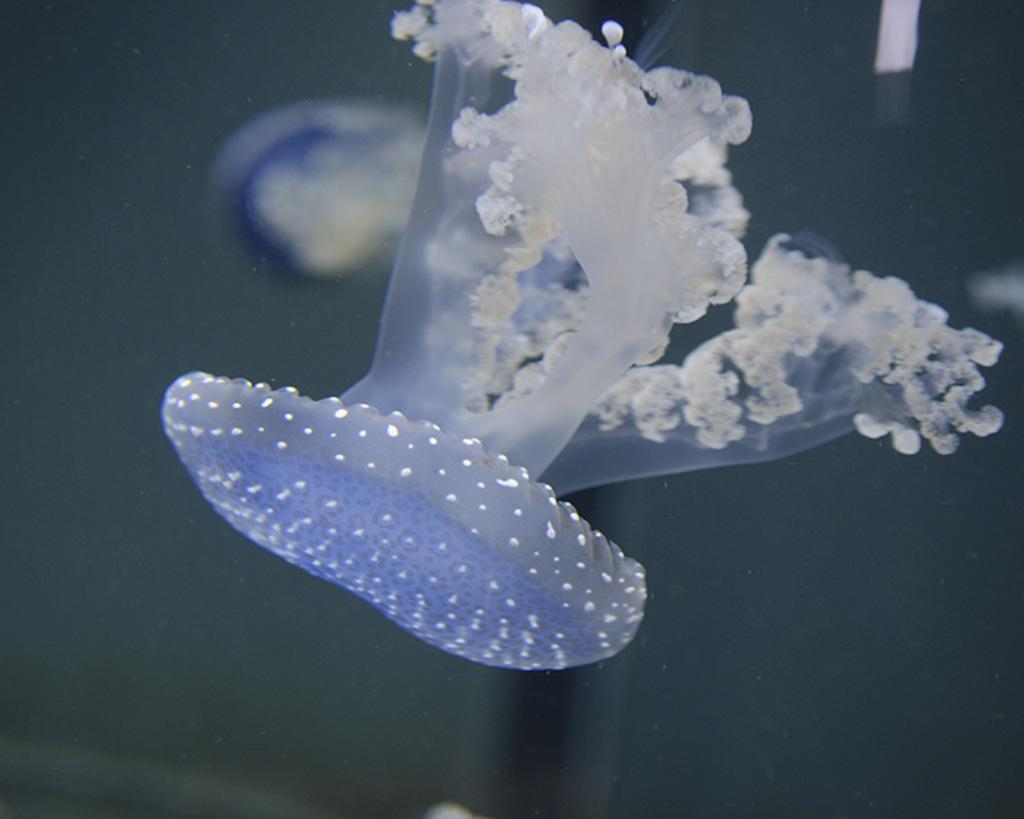What type of sea creature is present in the image? There is a jellyfish in the image. What type of lock can be seen securing the bean in the image? There is no lock or bean present in the image; it features a jellyfish. What color is the cap worn by the jellyfish in the image? Jellyfish do not wear caps, and there is no cap present in the image. 